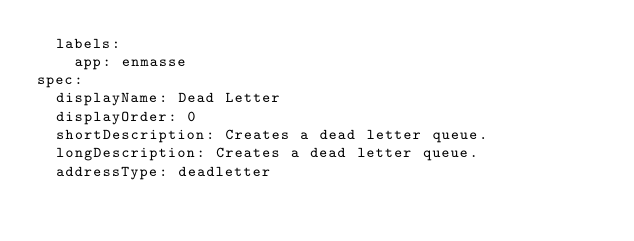Convert code to text. <code><loc_0><loc_0><loc_500><loc_500><_YAML_>  labels:
    app: enmasse
spec:
  displayName: Dead Letter
  displayOrder: 0
  shortDescription: Creates a dead letter queue.
  longDescription: Creates a dead letter queue.
  addressType: deadletter
</code> 